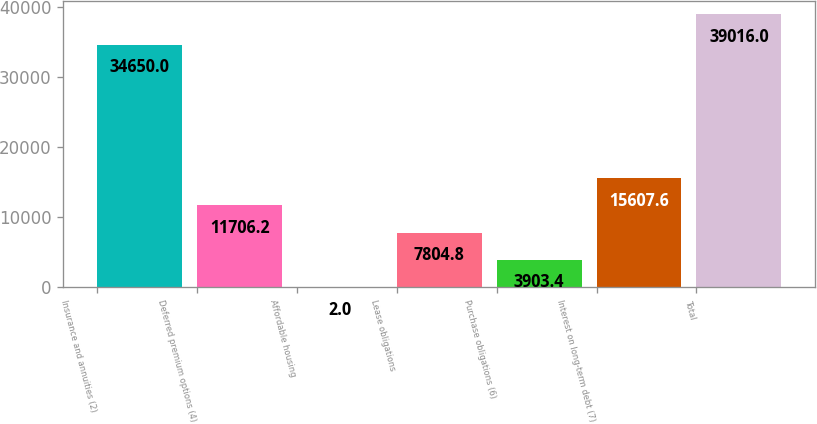Convert chart to OTSL. <chart><loc_0><loc_0><loc_500><loc_500><bar_chart><fcel>Insurance and annuities (2)<fcel>Deferred premium options (4)<fcel>Affordable housing<fcel>Lease obligations<fcel>Purchase obligations (6)<fcel>Interest on long-term debt (7)<fcel>Total<nl><fcel>34650<fcel>11706.2<fcel>2<fcel>7804.8<fcel>3903.4<fcel>15607.6<fcel>39016<nl></chart> 